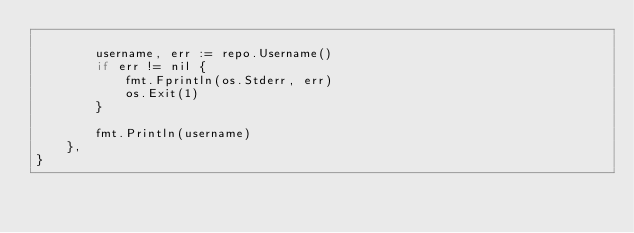<code> <loc_0><loc_0><loc_500><loc_500><_Go_>
		username, err := repo.Username()
		if err != nil {
			fmt.Fprintln(os.Stderr, err)
			os.Exit(1)
		}

		fmt.Println(username)
	},
}
</code> 